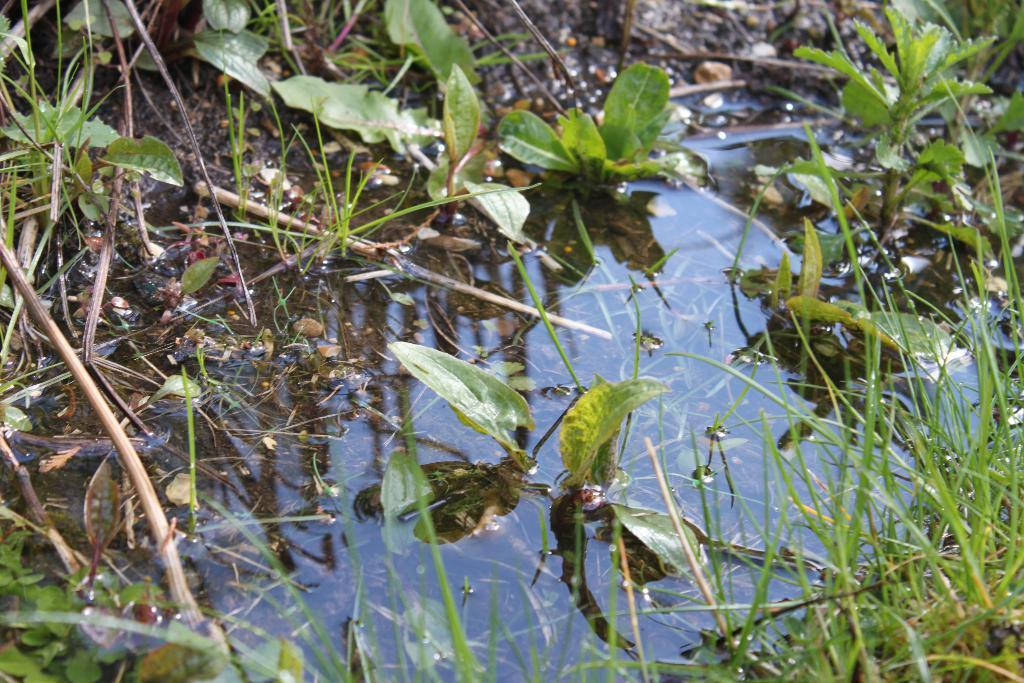What is visible in the image? Water, grass, and green-colored leaves are visible in the image. Can you describe the type of vegetation present in the image? The vegetation present in the image includes grass and green-colored leaves. What is the primary color of the leaves in the image? The primary color of the leaves in the image is green. What type of root can be seen growing in the water in the image? There is no root visible in the water in the image. What idea is being conveyed through the image? The image does not convey any specific idea; it simply depicts water, grass, and green-colored leaves. 